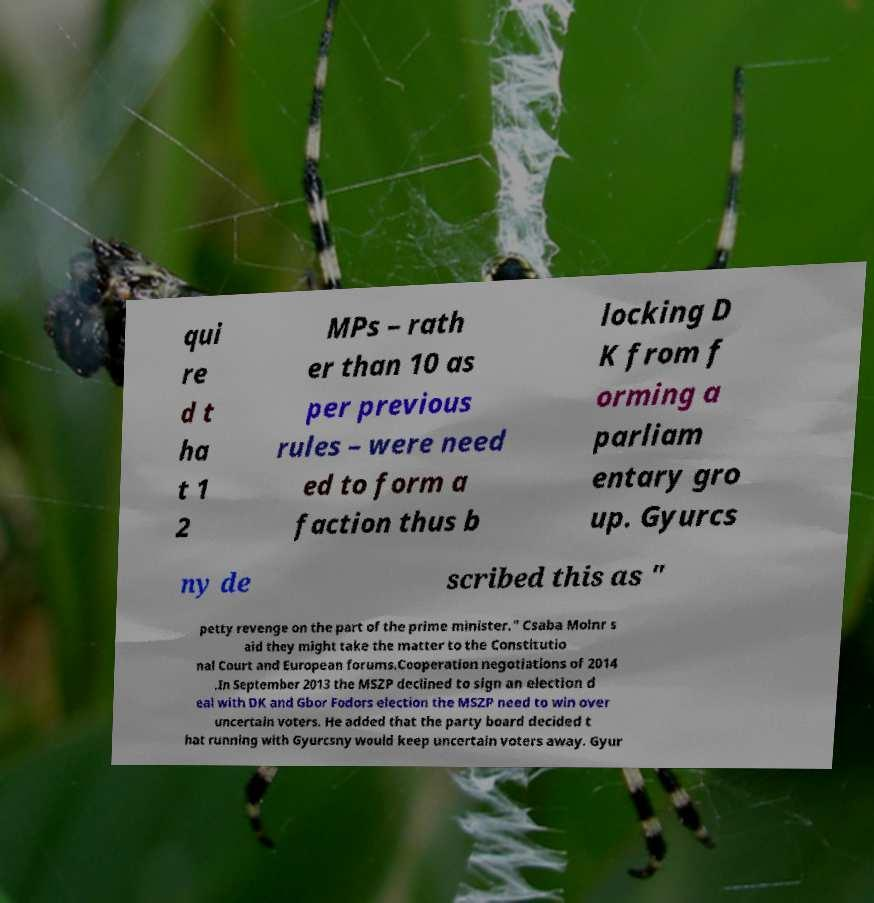I need the written content from this picture converted into text. Can you do that? qui re d t ha t 1 2 MPs – rath er than 10 as per previous rules – were need ed to form a faction thus b locking D K from f orming a parliam entary gro up. Gyurcs ny de scribed this as " petty revenge on the part of the prime minister." Csaba Molnr s aid they might take the matter to the Constitutio nal Court and European forums.Cooperation negotiations of 2014 .In September 2013 the MSZP declined to sign an election d eal with DK and Gbor Fodors election the MSZP need to win over uncertain voters. He added that the party board decided t hat running with Gyurcsny would keep uncertain voters away. Gyur 